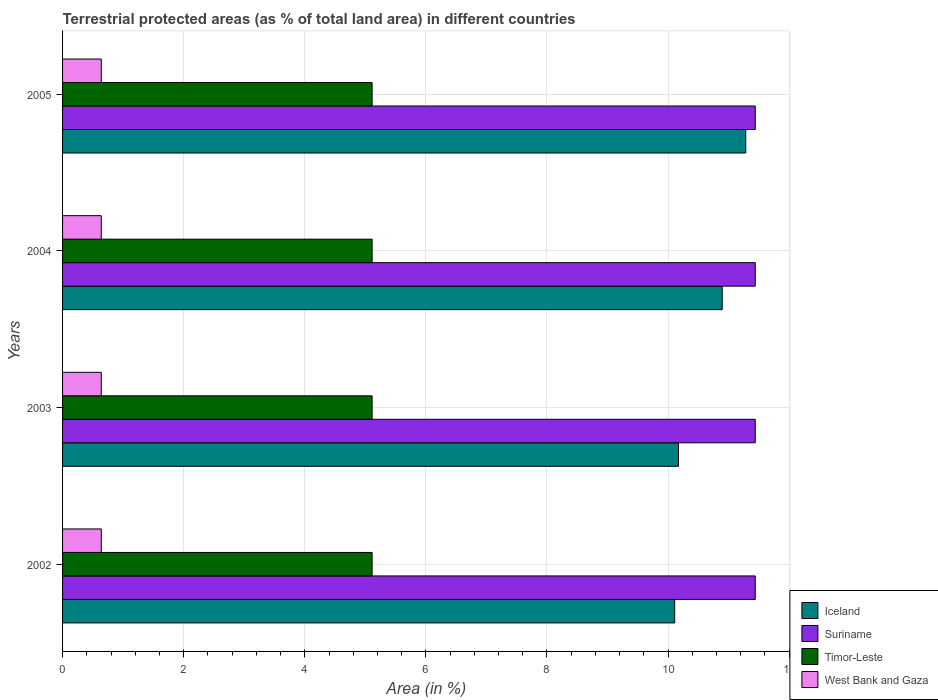Are the number of bars on each tick of the Y-axis equal?
Your answer should be compact. Yes. How many bars are there on the 3rd tick from the top?
Your answer should be very brief. 4. How many bars are there on the 3rd tick from the bottom?
Offer a very short reply. 4. In how many cases, is the number of bars for a given year not equal to the number of legend labels?
Ensure brevity in your answer.  0. What is the percentage of terrestrial protected land in Suriname in 2002?
Your answer should be compact. 11.44. Across all years, what is the maximum percentage of terrestrial protected land in Timor-Leste?
Your answer should be compact. 5.11. Across all years, what is the minimum percentage of terrestrial protected land in Suriname?
Your answer should be compact. 11.44. What is the total percentage of terrestrial protected land in Iceland in the graph?
Your response must be concise. 42.46. What is the difference between the percentage of terrestrial protected land in Iceland in 2002 and that in 2004?
Ensure brevity in your answer.  -0.78. What is the difference between the percentage of terrestrial protected land in Iceland in 2004 and the percentage of terrestrial protected land in Suriname in 2002?
Your response must be concise. -0.55. What is the average percentage of terrestrial protected land in Iceland per year?
Your answer should be compact. 10.61. In the year 2004, what is the difference between the percentage of terrestrial protected land in Timor-Leste and percentage of terrestrial protected land in West Bank and Gaza?
Offer a very short reply. 4.47. What is the ratio of the percentage of terrestrial protected land in Iceland in 2002 to that in 2004?
Provide a succinct answer. 0.93. Is the percentage of terrestrial protected land in Iceland in 2002 less than that in 2004?
Offer a very short reply. Yes. What is the difference between the highest and the lowest percentage of terrestrial protected land in West Bank and Gaza?
Offer a very short reply. 0. In how many years, is the percentage of terrestrial protected land in Iceland greater than the average percentage of terrestrial protected land in Iceland taken over all years?
Provide a succinct answer. 2. What does the 1st bar from the top in 2004 represents?
Offer a very short reply. West Bank and Gaza. What does the 3rd bar from the bottom in 2003 represents?
Ensure brevity in your answer.  Timor-Leste. How many bars are there?
Offer a terse response. 16. Are all the bars in the graph horizontal?
Provide a short and direct response. Yes. Does the graph contain grids?
Provide a succinct answer. Yes. How many legend labels are there?
Ensure brevity in your answer.  4. What is the title of the graph?
Provide a succinct answer. Terrestrial protected areas (as % of total land area) in different countries. Does "Kazakhstan" appear as one of the legend labels in the graph?
Make the answer very short. No. What is the label or title of the X-axis?
Provide a succinct answer. Area (in %). What is the label or title of the Y-axis?
Offer a very short reply. Years. What is the Area (in %) in Iceland in 2002?
Offer a very short reply. 10.11. What is the Area (in %) in Suriname in 2002?
Provide a succinct answer. 11.44. What is the Area (in %) in Timor-Leste in 2002?
Your answer should be very brief. 5.11. What is the Area (in %) in West Bank and Gaza in 2002?
Your answer should be very brief. 0.64. What is the Area (in %) of Iceland in 2003?
Give a very brief answer. 10.17. What is the Area (in %) of Suriname in 2003?
Your answer should be very brief. 11.44. What is the Area (in %) of Timor-Leste in 2003?
Make the answer very short. 5.11. What is the Area (in %) in West Bank and Gaza in 2003?
Offer a very short reply. 0.64. What is the Area (in %) of Iceland in 2004?
Provide a succinct answer. 10.89. What is the Area (in %) in Suriname in 2004?
Offer a terse response. 11.44. What is the Area (in %) of Timor-Leste in 2004?
Make the answer very short. 5.11. What is the Area (in %) of West Bank and Gaza in 2004?
Your answer should be very brief. 0.64. What is the Area (in %) in Iceland in 2005?
Your answer should be compact. 11.28. What is the Area (in %) in Suriname in 2005?
Offer a terse response. 11.44. What is the Area (in %) of Timor-Leste in 2005?
Your answer should be compact. 5.11. What is the Area (in %) of West Bank and Gaza in 2005?
Your response must be concise. 0.64. Across all years, what is the maximum Area (in %) of Iceland?
Ensure brevity in your answer.  11.28. Across all years, what is the maximum Area (in %) in Suriname?
Provide a short and direct response. 11.44. Across all years, what is the maximum Area (in %) of Timor-Leste?
Your answer should be very brief. 5.11. Across all years, what is the maximum Area (in %) of West Bank and Gaza?
Make the answer very short. 0.64. Across all years, what is the minimum Area (in %) in Iceland?
Provide a short and direct response. 10.11. Across all years, what is the minimum Area (in %) of Suriname?
Your response must be concise. 11.44. Across all years, what is the minimum Area (in %) of Timor-Leste?
Your response must be concise. 5.11. Across all years, what is the minimum Area (in %) of West Bank and Gaza?
Provide a short and direct response. 0.64. What is the total Area (in %) in Iceland in the graph?
Give a very brief answer. 42.46. What is the total Area (in %) of Suriname in the graph?
Make the answer very short. 45.76. What is the total Area (in %) of Timor-Leste in the graph?
Your answer should be very brief. 20.45. What is the total Area (in %) in West Bank and Gaza in the graph?
Ensure brevity in your answer.  2.56. What is the difference between the Area (in %) of Iceland in 2002 and that in 2003?
Provide a succinct answer. -0.06. What is the difference between the Area (in %) in Suriname in 2002 and that in 2003?
Give a very brief answer. 0. What is the difference between the Area (in %) of West Bank and Gaza in 2002 and that in 2003?
Offer a terse response. 0. What is the difference between the Area (in %) in Iceland in 2002 and that in 2004?
Provide a succinct answer. -0.78. What is the difference between the Area (in %) in Iceland in 2002 and that in 2005?
Your answer should be compact. -1.17. What is the difference between the Area (in %) in West Bank and Gaza in 2002 and that in 2005?
Offer a terse response. 0. What is the difference between the Area (in %) in Iceland in 2003 and that in 2004?
Provide a short and direct response. -0.72. What is the difference between the Area (in %) of Suriname in 2003 and that in 2004?
Provide a short and direct response. 0. What is the difference between the Area (in %) in West Bank and Gaza in 2003 and that in 2004?
Make the answer very short. 0. What is the difference between the Area (in %) of Iceland in 2003 and that in 2005?
Offer a very short reply. -1.11. What is the difference between the Area (in %) in Iceland in 2004 and that in 2005?
Offer a terse response. -0.39. What is the difference between the Area (in %) in Suriname in 2004 and that in 2005?
Your answer should be compact. 0. What is the difference between the Area (in %) of Iceland in 2002 and the Area (in %) of Suriname in 2003?
Your answer should be compact. -1.33. What is the difference between the Area (in %) in Iceland in 2002 and the Area (in %) in Timor-Leste in 2003?
Give a very brief answer. 5. What is the difference between the Area (in %) in Iceland in 2002 and the Area (in %) in West Bank and Gaza in 2003?
Provide a short and direct response. 9.47. What is the difference between the Area (in %) in Suriname in 2002 and the Area (in %) in Timor-Leste in 2003?
Keep it short and to the point. 6.33. What is the difference between the Area (in %) of Suriname in 2002 and the Area (in %) of West Bank and Gaza in 2003?
Your response must be concise. 10.8. What is the difference between the Area (in %) of Timor-Leste in 2002 and the Area (in %) of West Bank and Gaza in 2003?
Keep it short and to the point. 4.47. What is the difference between the Area (in %) in Iceland in 2002 and the Area (in %) in Suriname in 2004?
Your response must be concise. -1.33. What is the difference between the Area (in %) of Iceland in 2002 and the Area (in %) of Timor-Leste in 2004?
Your answer should be compact. 5. What is the difference between the Area (in %) in Iceland in 2002 and the Area (in %) in West Bank and Gaza in 2004?
Make the answer very short. 9.47. What is the difference between the Area (in %) of Suriname in 2002 and the Area (in %) of Timor-Leste in 2004?
Keep it short and to the point. 6.33. What is the difference between the Area (in %) in Suriname in 2002 and the Area (in %) in West Bank and Gaza in 2004?
Keep it short and to the point. 10.8. What is the difference between the Area (in %) in Timor-Leste in 2002 and the Area (in %) in West Bank and Gaza in 2004?
Ensure brevity in your answer.  4.47. What is the difference between the Area (in %) of Iceland in 2002 and the Area (in %) of Suriname in 2005?
Offer a very short reply. -1.33. What is the difference between the Area (in %) of Iceland in 2002 and the Area (in %) of Timor-Leste in 2005?
Your answer should be very brief. 5. What is the difference between the Area (in %) of Iceland in 2002 and the Area (in %) of West Bank and Gaza in 2005?
Your answer should be compact. 9.47. What is the difference between the Area (in %) of Suriname in 2002 and the Area (in %) of Timor-Leste in 2005?
Give a very brief answer. 6.33. What is the difference between the Area (in %) of Suriname in 2002 and the Area (in %) of West Bank and Gaza in 2005?
Your answer should be compact. 10.8. What is the difference between the Area (in %) in Timor-Leste in 2002 and the Area (in %) in West Bank and Gaza in 2005?
Give a very brief answer. 4.47. What is the difference between the Area (in %) of Iceland in 2003 and the Area (in %) of Suriname in 2004?
Your answer should be very brief. -1.27. What is the difference between the Area (in %) in Iceland in 2003 and the Area (in %) in Timor-Leste in 2004?
Offer a terse response. 5.06. What is the difference between the Area (in %) in Iceland in 2003 and the Area (in %) in West Bank and Gaza in 2004?
Offer a very short reply. 9.53. What is the difference between the Area (in %) of Suriname in 2003 and the Area (in %) of Timor-Leste in 2004?
Offer a very short reply. 6.33. What is the difference between the Area (in %) of Suriname in 2003 and the Area (in %) of West Bank and Gaza in 2004?
Keep it short and to the point. 10.8. What is the difference between the Area (in %) in Timor-Leste in 2003 and the Area (in %) in West Bank and Gaza in 2004?
Make the answer very short. 4.47. What is the difference between the Area (in %) of Iceland in 2003 and the Area (in %) of Suriname in 2005?
Offer a terse response. -1.27. What is the difference between the Area (in %) of Iceland in 2003 and the Area (in %) of Timor-Leste in 2005?
Offer a very short reply. 5.06. What is the difference between the Area (in %) of Iceland in 2003 and the Area (in %) of West Bank and Gaza in 2005?
Provide a short and direct response. 9.53. What is the difference between the Area (in %) in Suriname in 2003 and the Area (in %) in Timor-Leste in 2005?
Ensure brevity in your answer.  6.33. What is the difference between the Area (in %) of Suriname in 2003 and the Area (in %) of West Bank and Gaza in 2005?
Keep it short and to the point. 10.8. What is the difference between the Area (in %) in Timor-Leste in 2003 and the Area (in %) in West Bank and Gaza in 2005?
Provide a short and direct response. 4.47. What is the difference between the Area (in %) of Iceland in 2004 and the Area (in %) of Suriname in 2005?
Offer a very short reply. -0.55. What is the difference between the Area (in %) of Iceland in 2004 and the Area (in %) of Timor-Leste in 2005?
Your response must be concise. 5.78. What is the difference between the Area (in %) of Iceland in 2004 and the Area (in %) of West Bank and Gaza in 2005?
Your response must be concise. 10.25. What is the difference between the Area (in %) of Suriname in 2004 and the Area (in %) of Timor-Leste in 2005?
Provide a short and direct response. 6.33. What is the difference between the Area (in %) of Suriname in 2004 and the Area (in %) of West Bank and Gaza in 2005?
Give a very brief answer. 10.8. What is the difference between the Area (in %) of Timor-Leste in 2004 and the Area (in %) of West Bank and Gaza in 2005?
Give a very brief answer. 4.47. What is the average Area (in %) of Iceland per year?
Offer a terse response. 10.61. What is the average Area (in %) in Suriname per year?
Your response must be concise. 11.44. What is the average Area (in %) in Timor-Leste per year?
Ensure brevity in your answer.  5.11. What is the average Area (in %) in West Bank and Gaza per year?
Your answer should be compact. 0.64. In the year 2002, what is the difference between the Area (in %) of Iceland and Area (in %) of Suriname?
Provide a succinct answer. -1.33. In the year 2002, what is the difference between the Area (in %) in Iceland and Area (in %) in Timor-Leste?
Give a very brief answer. 5. In the year 2002, what is the difference between the Area (in %) of Iceland and Area (in %) of West Bank and Gaza?
Ensure brevity in your answer.  9.47. In the year 2002, what is the difference between the Area (in %) of Suriname and Area (in %) of Timor-Leste?
Your response must be concise. 6.33. In the year 2002, what is the difference between the Area (in %) of Suriname and Area (in %) of West Bank and Gaza?
Offer a terse response. 10.8. In the year 2002, what is the difference between the Area (in %) in Timor-Leste and Area (in %) in West Bank and Gaza?
Ensure brevity in your answer.  4.47. In the year 2003, what is the difference between the Area (in %) of Iceland and Area (in %) of Suriname?
Your response must be concise. -1.27. In the year 2003, what is the difference between the Area (in %) of Iceland and Area (in %) of Timor-Leste?
Give a very brief answer. 5.06. In the year 2003, what is the difference between the Area (in %) of Iceland and Area (in %) of West Bank and Gaza?
Provide a succinct answer. 9.53. In the year 2003, what is the difference between the Area (in %) in Suriname and Area (in %) in Timor-Leste?
Your response must be concise. 6.33. In the year 2003, what is the difference between the Area (in %) of Suriname and Area (in %) of West Bank and Gaza?
Keep it short and to the point. 10.8. In the year 2003, what is the difference between the Area (in %) in Timor-Leste and Area (in %) in West Bank and Gaza?
Provide a succinct answer. 4.47. In the year 2004, what is the difference between the Area (in %) of Iceland and Area (in %) of Suriname?
Offer a terse response. -0.55. In the year 2004, what is the difference between the Area (in %) in Iceland and Area (in %) in Timor-Leste?
Offer a terse response. 5.78. In the year 2004, what is the difference between the Area (in %) in Iceland and Area (in %) in West Bank and Gaza?
Offer a very short reply. 10.25. In the year 2004, what is the difference between the Area (in %) in Suriname and Area (in %) in Timor-Leste?
Provide a short and direct response. 6.33. In the year 2004, what is the difference between the Area (in %) of Suriname and Area (in %) of West Bank and Gaza?
Your answer should be compact. 10.8. In the year 2004, what is the difference between the Area (in %) of Timor-Leste and Area (in %) of West Bank and Gaza?
Ensure brevity in your answer.  4.47. In the year 2005, what is the difference between the Area (in %) of Iceland and Area (in %) of Suriname?
Ensure brevity in your answer.  -0.16. In the year 2005, what is the difference between the Area (in %) of Iceland and Area (in %) of Timor-Leste?
Give a very brief answer. 6.17. In the year 2005, what is the difference between the Area (in %) of Iceland and Area (in %) of West Bank and Gaza?
Provide a short and direct response. 10.64. In the year 2005, what is the difference between the Area (in %) of Suriname and Area (in %) of Timor-Leste?
Offer a very short reply. 6.33. In the year 2005, what is the difference between the Area (in %) in Suriname and Area (in %) in West Bank and Gaza?
Your answer should be compact. 10.8. In the year 2005, what is the difference between the Area (in %) of Timor-Leste and Area (in %) of West Bank and Gaza?
Your answer should be compact. 4.47. What is the ratio of the Area (in %) of Iceland in 2002 to that in 2003?
Provide a succinct answer. 0.99. What is the ratio of the Area (in %) in Suriname in 2002 to that in 2003?
Make the answer very short. 1. What is the ratio of the Area (in %) of West Bank and Gaza in 2002 to that in 2003?
Your response must be concise. 1. What is the ratio of the Area (in %) in Iceland in 2002 to that in 2004?
Offer a very short reply. 0.93. What is the ratio of the Area (in %) in Suriname in 2002 to that in 2004?
Ensure brevity in your answer.  1. What is the ratio of the Area (in %) of West Bank and Gaza in 2002 to that in 2004?
Keep it short and to the point. 1. What is the ratio of the Area (in %) of Iceland in 2002 to that in 2005?
Your answer should be compact. 0.9. What is the ratio of the Area (in %) in West Bank and Gaza in 2002 to that in 2005?
Your answer should be very brief. 1. What is the ratio of the Area (in %) in Iceland in 2003 to that in 2004?
Offer a terse response. 0.93. What is the ratio of the Area (in %) of Suriname in 2003 to that in 2004?
Provide a short and direct response. 1. What is the ratio of the Area (in %) in Iceland in 2003 to that in 2005?
Offer a terse response. 0.9. What is the ratio of the Area (in %) of Suriname in 2003 to that in 2005?
Make the answer very short. 1. What is the ratio of the Area (in %) of Iceland in 2004 to that in 2005?
Your answer should be very brief. 0.97. What is the ratio of the Area (in %) of Suriname in 2004 to that in 2005?
Offer a very short reply. 1. What is the ratio of the Area (in %) of Timor-Leste in 2004 to that in 2005?
Your answer should be very brief. 1. What is the ratio of the Area (in %) of West Bank and Gaza in 2004 to that in 2005?
Keep it short and to the point. 1. What is the difference between the highest and the second highest Area (in %) in Iceland?
Your answer should be very brief. 0.39. What is the difference between the highest and the lowest Area (in %) of Iceland?
Your answer should be compact. 1.17. What is the difference between the highest and the lowest Area (in %) in Suriname?
Make the answer very short. 0. What is the difference between the highest and the lowest Area (in %) in Timor-Leste?
Make the answer very short. 0. What is the difference between the highest and the lowest Area (in %) in West Bank and Gaza?
Your answer should be compact. 0. 